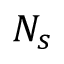Convert formula to latex. <formula><loc_0><loc_0><loc_500><loc_500>N _ { s }</formula> 